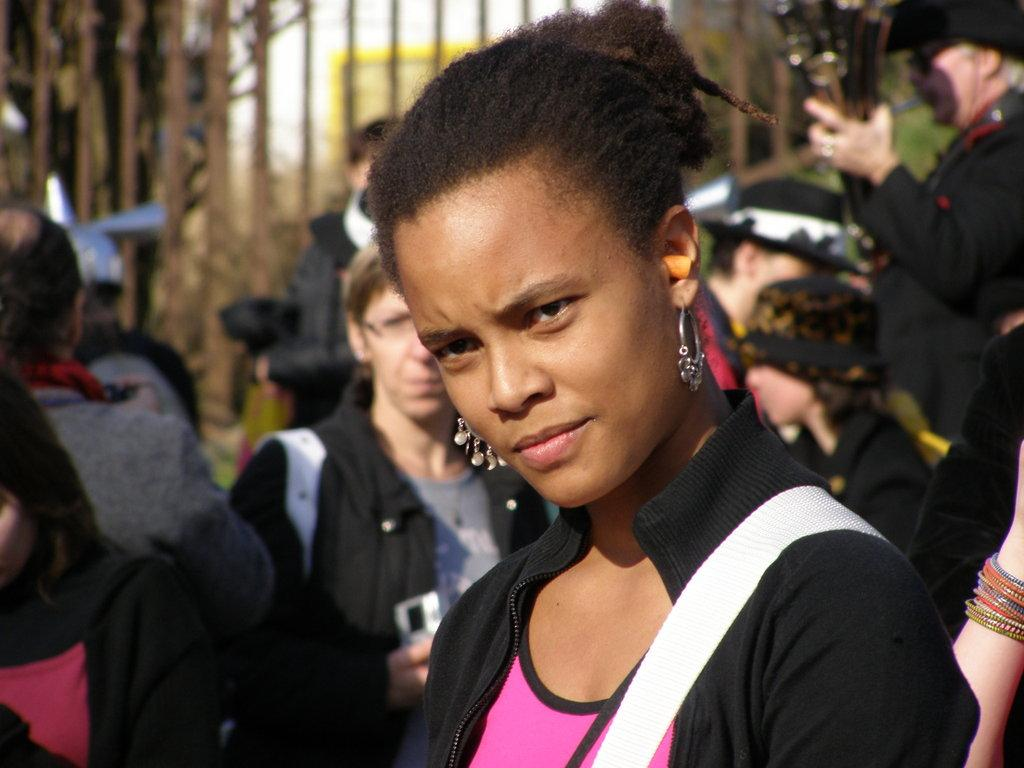Who is the main subject in the picture? There is a woman in the middle of the picture. Can you describe the background of the picture? There are people in the background of the picture. What type of linen is being used to cover the earth in the image? There is no linen or reference to the earth present in the image; it features a woman and people in the background. 